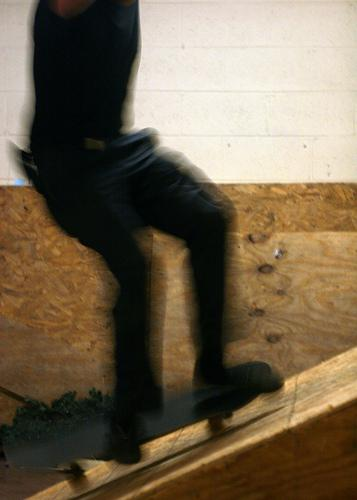Question: what is the color of the dress?
Choices:
A. Blue.
B. Purple.
C. Red.
D. Black.
Answer with the letter. Answer: D Question: what is the man doing?
Choices:
A. Reading.
B. Sleeping.
C. Skating.
D. Eating.
Answer with the letter. Answer: C Question: where is he skating?
Choices:
A. In the wooden slope.
B. On the street.
C. On the rails of the stairs.
D. By the beach.
Answer with the letter. Answer: A Question: what is the color of the leaves?
Choices:
A. Brown.
B. Orange.
C. Red.
D. Green.
Answer with the letter. Answer: D 